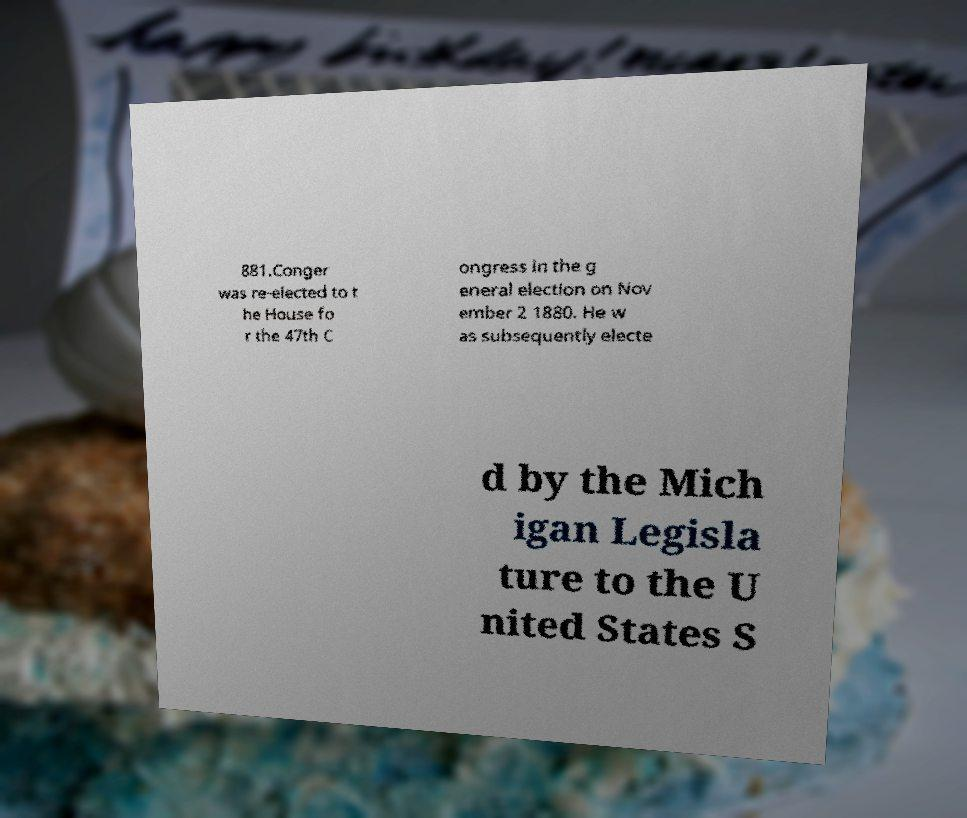Please identify and transcribe the text found in this image. 881.Conger was re-elected to t he House fo r the 47th C ongress in the g eneral election on Nov ember 2 1880. He w as subsequently electe d by the Mich igan Legisla ture to the U nited States S 